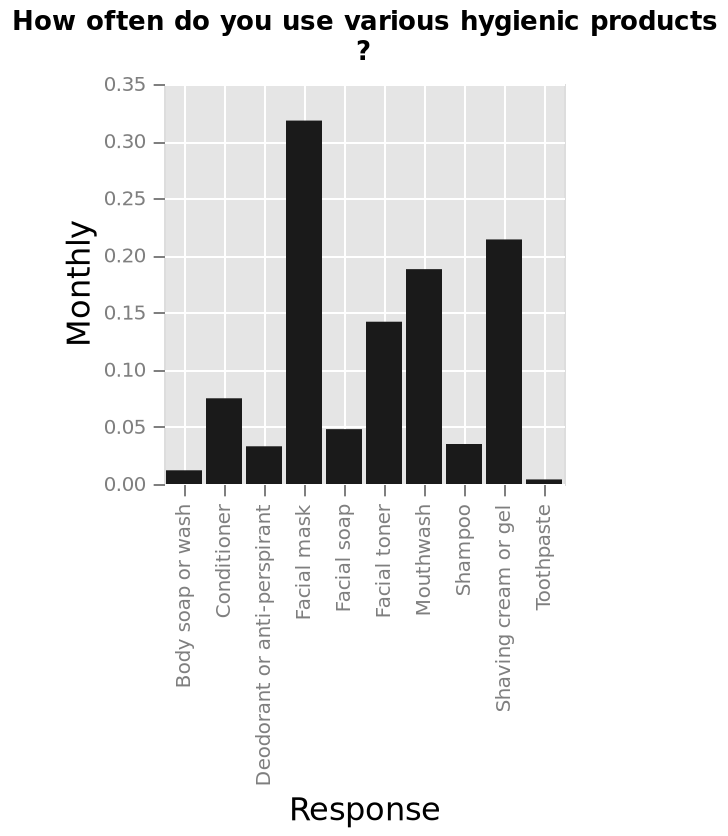<image>
Describe the following image in detail Here a is a bar diagram labeled How often do you use various hygienic products ?. The x-axis plots Response using categorical scale from Body soap or wash to Toothpaste while the y-axis shows Monthly using scale with a minimum of 0.00 and a maximum of 0.35. What is the x-axis of the bar diagram labeled "How often do you use various hygienic products"?  The x-axis of the bar diagram is labeled from "Body soap or wash" to "Toothpaste" using a categorical scale. 